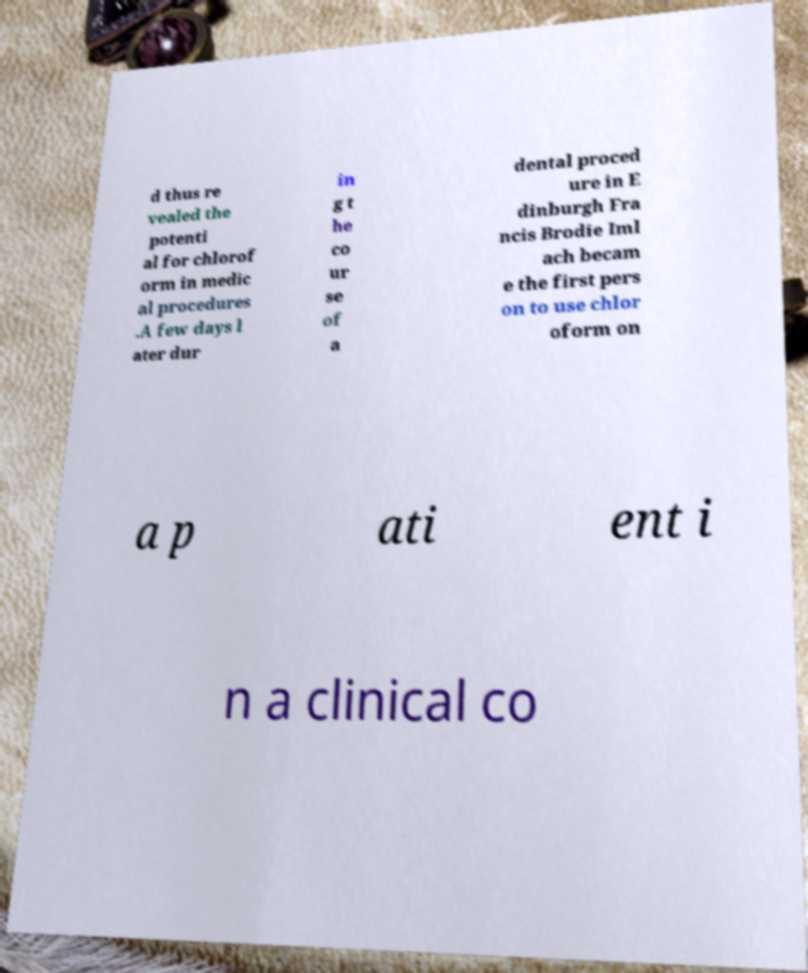Can you accurately transcribe the text from the provided image for me? d thus re vealed the potenti al for chlorof orm in medic al procedures .A few days l ater dur in g t he co ur se of a dental proced ure in E dinburgh Fra ncis Brodie Iml ach becam e the first pers on to use chlor oform on a p ati ent i n a clinical co 